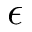Convert formula to latex. <formula><loc_0><loc_0><loc_500><loc_500>\epsilon</formula> 